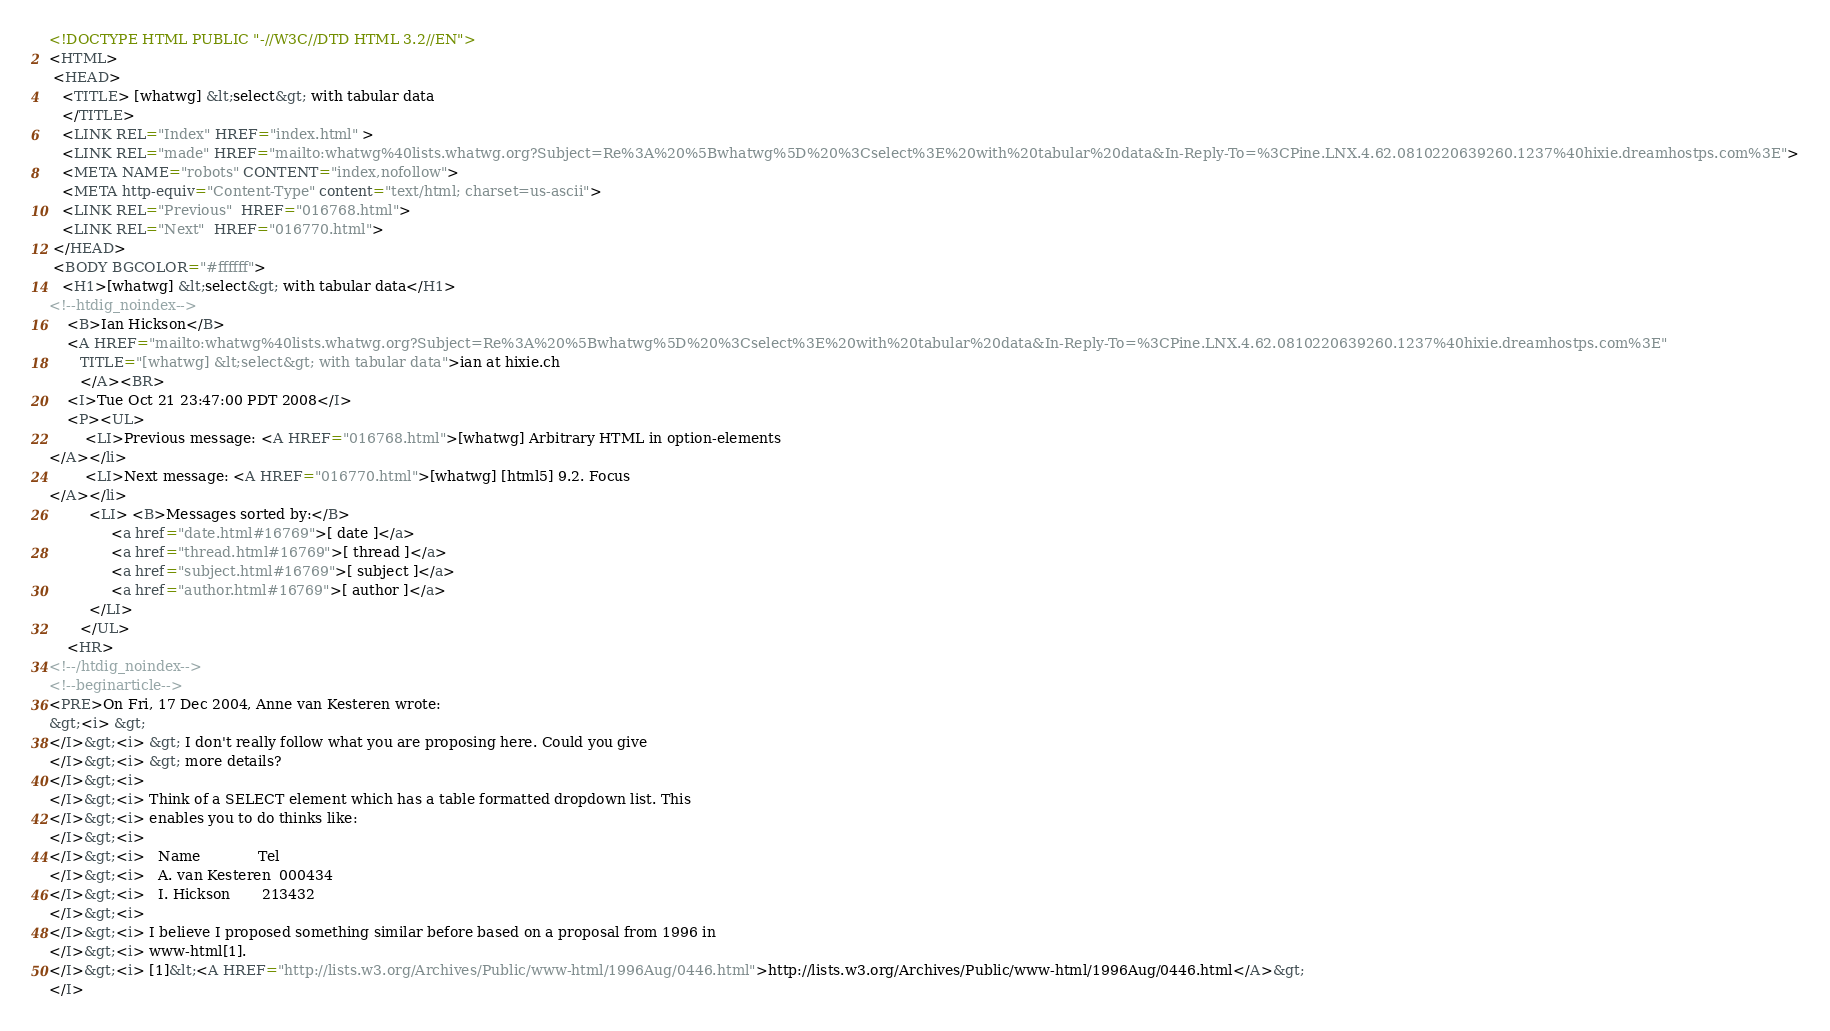Convert code to text. <code><loc_0><loc_0><loc_500><loc_500><_HTML_><!DOCTYPE HTML PUBLIC "-//W3C//DTD HTML 3.2//EN">
<HTML>
 <HEAD>
   <TITLE> [whatwg] &lt;select&gt; with tabular data
   </TITLE>
   <LINK REL="Index" HREF="index.html" >
   <LINK REL="made" HREF="mailto:whatwg%40lists.whatwg.org?Subject=Re%3A%20%5Bwhatwg%5D%20%3Cselect%3E%20with%20tabular%20data&In-Reply-To=%3CPine.LNX.4.62.0810220639260.1237%40hixie.dreamhostps.com%3E">
   <META NAME="robots" CONTENT="index,nofollow">
   <META http-equiv="Content-Type" content="text/html; charset=us-ascii">
   <LINK REL="Previous"  HREF="016768.html">
   <LINK REL="Next"  HREF="016770.html">
 </HEAD>
 <BODY BGCOLOR="#ffffff">
   <H1>[whatwg] &lt;select&gt; with tabular data</H1>
<!--htdig_noindex-->
    <B>Ian Hickson</B> 
    <A HREF="mailto:whatwg%40lists.whatwg.org?Subject=Re%3A%20%5Bwhatwg%5D%20%3Cselect%3E%20with%20tabular%20data&In-Reply-To=%3CPine.LNX.4.62.0810220639260.1237%40hixie.dreamhostps.com%3E"
       TITLE="[whatwg] &lt;select&gt; with tabular data">ian at hixie.ch
       </A><BR>
    <I>Tue Oct 21 23:47:00 PDT 2008</I>
    <P><UL>
        <LI>Previous message: <A HREF="016768.html">[whatwg] Arbitrary HTML in option-elements
</A></li>
        <LI>Next message: <A HREF="016770.html">[whatwg] [html5] 9.2. Focus
</A></li>
         <LI> <B>Messages sorted by:</B> 
              <a href="date.html#16769">[ date ]</a>
              <a href="thread.html#16769">[ thread ]</a>
              <a href="subject.html#16769">[ subject ]</a>
              <a href="author.html#16769">[ author ]</a>
         </LI>
       </UL>
    <HR>  
<!--/htdig_noindex-->
<!--beginarticle-->
<PRE>On Fri, 17 Dec 2004, Anne van Kesteren wrote:
&gt;<i> &gt;
</I>&gt;<i> &gt; I don't really follow what you are proposing here. Could you give
</I>&gt;<i> &gt; more details?
</I>&gt;<i> 
</I>&gt;<i> Think of a SELECT element which has a table formatted dropdown list. This
</I>&gt;<i> enables you to do thinks like:
</I>&gt;<i> 
</I>&gt;<i>   Name             Tel
</I>&gt;<i>   A. van Kesteren  000434
</I>&gt;<i>   I. Hickson       213432
</I>&gt;<i> 
</I>&gt;<i> I believe I proposed something similar before based on a proposal from 1996 in
</I>&gt;<i> www-html[1].
</I>&gt;<i> [1]&lt;<A HREF="http://lists.w3.org/Archives/Public/www-html/1996Aug/0446.html">http://lists.w3.org/Archives/Public/www-html/1996Aug/0446.html</A>&gt;
</I></code> 